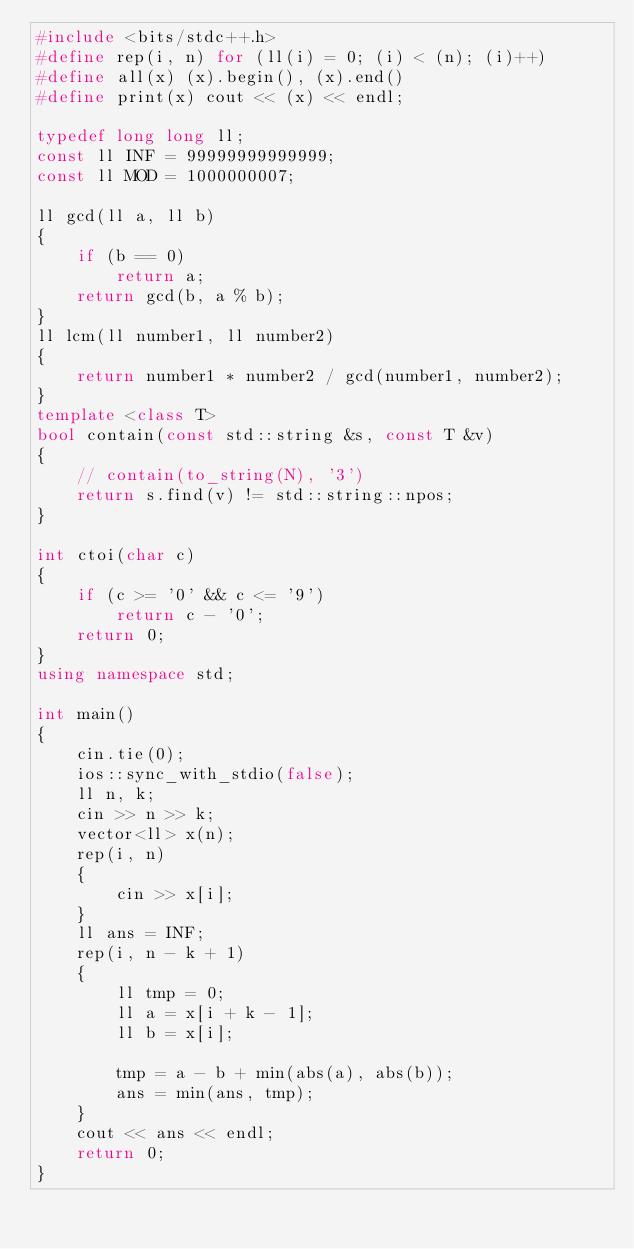Convert code to text. <code><loc_0><loc_0><loc_500><loc_500><_C++_>#include <bits/stdc++.h>
#define rep(i, n) for (ll(i) = 0; (i) < (n); (i)++)
#define all(x) (x).begin(), (x).end()
#define print(x) cout << (x) << endl;

typedef long long ll;
const ll INF = 99999999999999;
const ll MOD = 1000000007;

ll gcd(ll a, ll b)
{
    if (b == 0)
        return a;
    return gcd(b, a % b);
}
ll lcm(ll number1, ll number2)
{
    return number1 * number2 / gcd(number1, number2);
}
template <class T>
bool contain(const std::string &s, const T &v)
{
    // contain(to_string(N), '3')
    return s.find(v) != std::string::npos;
}

int ctoi(char c)
{
    if (c >= '0' && c <= '9')
        return c - '0';
    return 0;
}
using namespace std;

int main()
{
    cin.tie(0);
    ios::sync_with_stdio(false);
    ll n, k;
    cin >> n >> k;
    vector<ll> x(n);
    rep(i, n)
    {
        cin >> x[i];
    }
    ll ans = INF;
    rep(i, n - k + 1)
    {
        ll tmp = 0;
        ll a = x[i + k - 1];
        ll b = x[i];

        tmp = a - b + min(abs(a), abs(b));
        ans = min(ans, tmp);
    }
    cout << ans << endl;
    return 0;
}</code> 